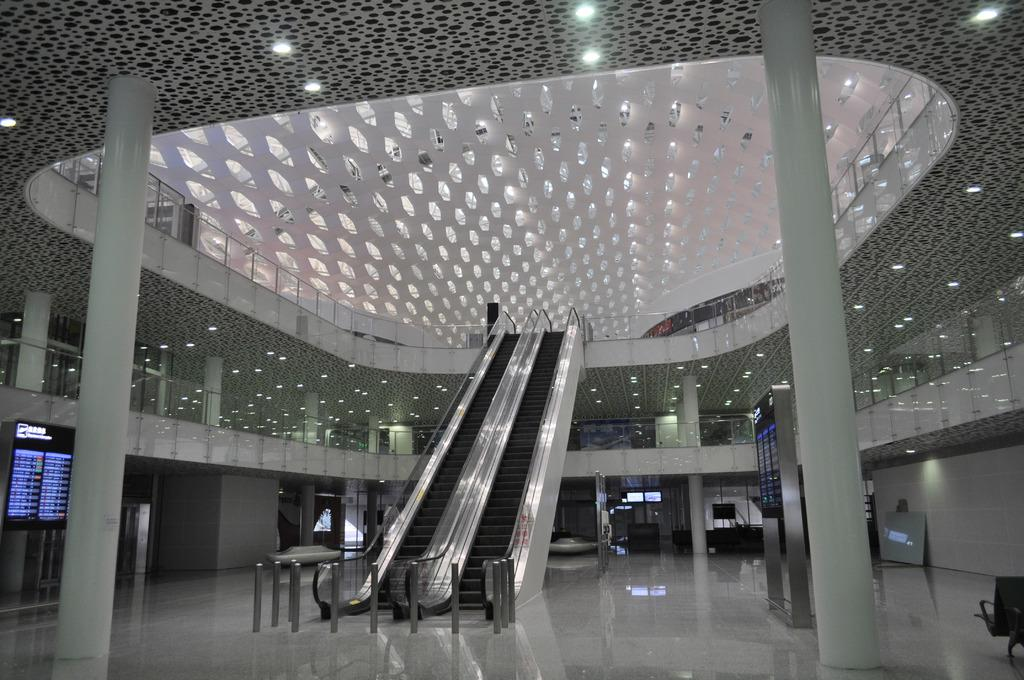What type of location is depicted in the image? The image shows an inside view of a building. What type of furniture can be seen in the image? There are chairs in the image. What architectural features are present in the image? There are pillars in the image. What type of lighting is present in the image? There are lights in the image. What type of transportation feature is present in the image? There are escalators in the image. What type of information display is present in the image? There are screen display boards in the image. What other objects can be seen in the image? There are other objects present in the image. How much salt is on the brother's flight in the image? There is no salt, brother, or flight present in the image. 